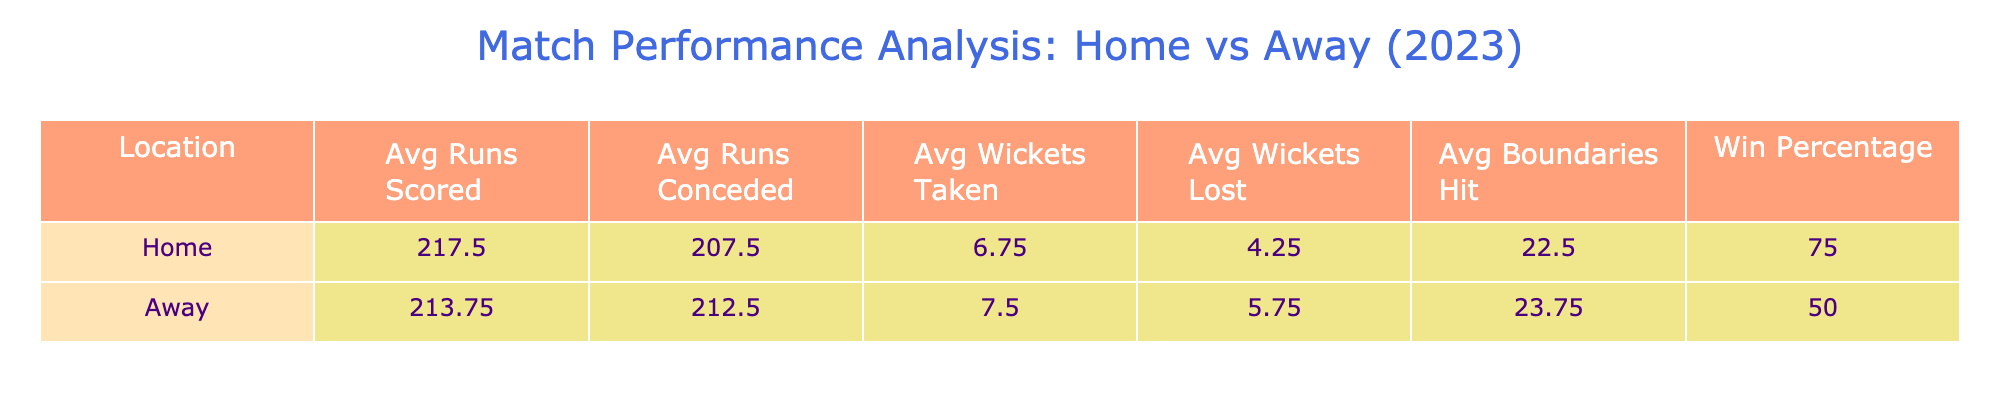What is the average number of runs scored in home games? The table shows that the average runs scored in home games is calculated by summing the runs scored in the home match (180, 250, 140, 300) and dividing by the number of home games (4). Therefore, the average is (180 + 250 + 140 + 300) / 4 = 217.5.
Answer: 217.5 What was the team's win percentage in away games? The win percentage in away games is calculated by the number of wins divided by the total number of away games played. The team won 2 out of 4 away games (against University of Lucknow and University of Hyderabad), giving a win percentage of (2/4) * 100 = 50%.
Answer: 50% How many boundaries did the team hit in total during home games? To find the total boundaries hit at home, we sum the boundaries hit from each home game (20, 25, 10, 35). Thus, the total is 20 + 25 + 10 + 35 = 90.
Answer: 90 Did the team score more runs on average at home or away? The average runs scored at home is 217.5 and away is 177.5 ((160 + 190 + 275 + 230) / 4). Since 217.5 > 177.5, the team scored more runs on average at home.
Answer: Yes What was the average number of wickets taken in home games compared to away games? The average wickets taken at home is (8 + 5 + 4 + 10) / 4 = 6.75 and for away games (6 + 9 + 8) / 4 = 7.25. Comparing both averages, home has less.
Answer: Wickets taken at home (6.75) are less than away (7.25) 